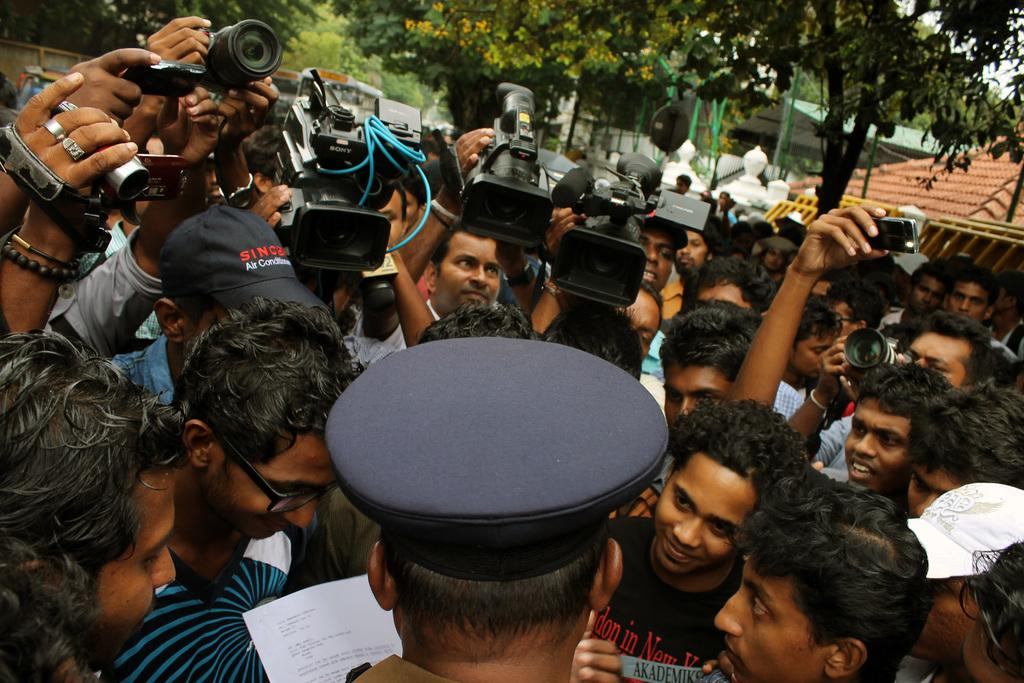Who or what is present in the image? There are people in the image. What are the people holding in their hands? The people are holding cameras. What can be seen in the background of the image? There are trees and a house in the background of the image. Can you see any fangs on the people in the image? There are no fangs visible on the people in the image. Does the existence of the house in the background imply that the people are in a cemetery? No, the presence of a house in the background does not imply that the people are in a cemetery; it simply indicates that there is a house nearby. 